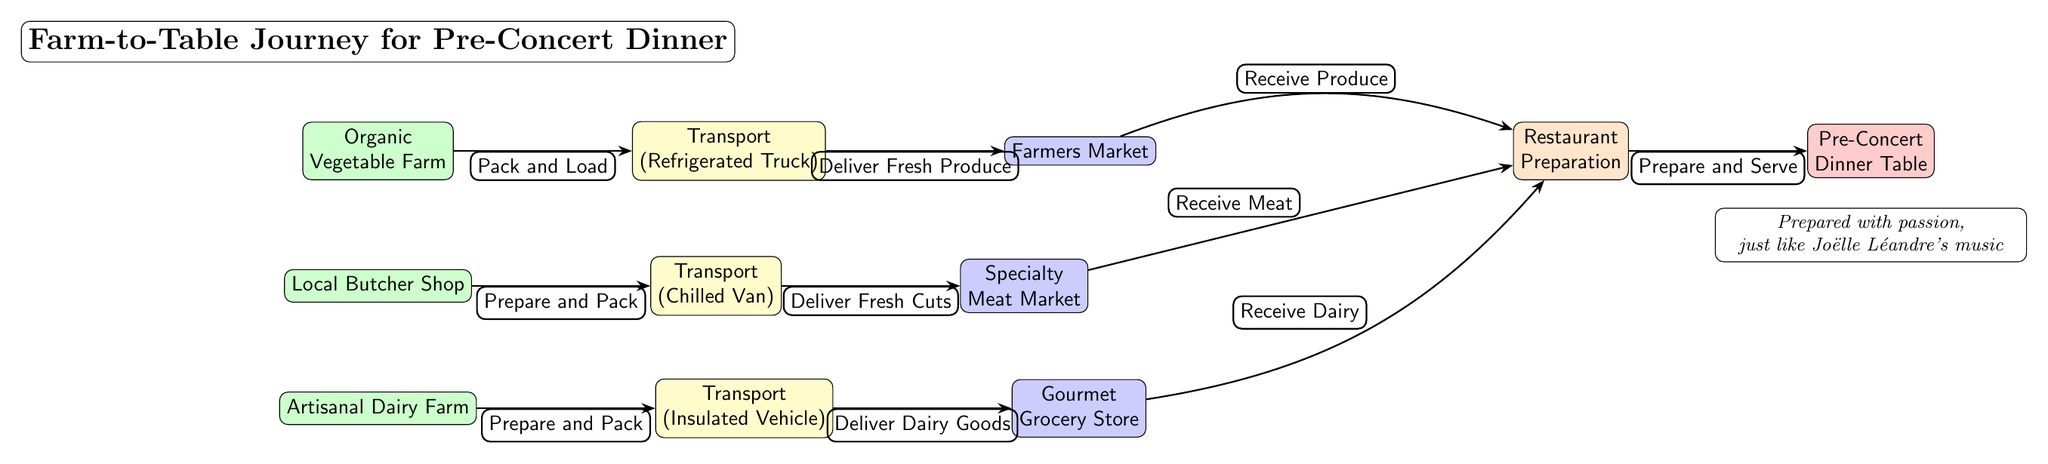What's the final destination of the food chain? The last node in the diagram is the "Pre-Concert Dinner Table," which represents the final destination where all ingredients are served after the preparation stage.
Answer: Pre-Concert Dinner Table How many farms are represented in the diagram? There are three different farms shown in the diagram: the Organic Vegetable Farm, the Local Butcher Shop, and the Artisanal Dairy Farm, totaling three farms.
Answer: 3 What is the first step in the transport process for vegetables? The first step for vegetable transportation is labeled "Pack and Load" which indicates that the vegetables are loaded into a refrigerated truck for delivery.
Answer: Pack and Load Which transportation method is used for the meat from the local butcher shop? The transportation method for meat is indicated as a "Chilled Van," specifically designed to keep the meat fresh during transit from the butcher to the market.
Answer: Chilled Van What products are received at the restaurant preparation stage? At the restaurant preparation stage, ingredients such as produce, meat, and dairy are received from their respective markets, indicating that all these elements are crucial for the pre-concert dinner.
Answer: Produce, Meat, Dairy How many markets are involved in the process for the ingredients? The diagram has three markets involved in the process: Farmers Market, Specialty Meat Market, and Gourmet Grocery Store, making a total of three markets.
Answer: 3 What is the overall theme of the prepared meal mentioned at the bottom of the diagram? The theme highlights the passion and care involved in meal preparation, drawing a parallel with Joëlle Léandre's music, suggesting a connection to artistry and dedication in both fields.
Answer: Prepared with passion What is the purpose of the insulated vehicle in the diagram? The insulated vehicle serves to transport dairy products, ensuring that they remain at the appropriate temperature to maintain freshness and quality before reaching the market.
Answer: Deliver Dairy Goods 